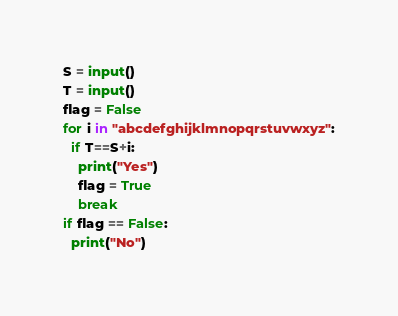<code> <loc_0><loc_0><loc_500><loc_500><_Python_>S = input()
T = input()
flag = False
for i in "abcdefghijklmnopqrstuvwxyz":
  if T==S+i:
    print("Yes")
    flag = True
    break
if flag == False:
  print("No")</code> 